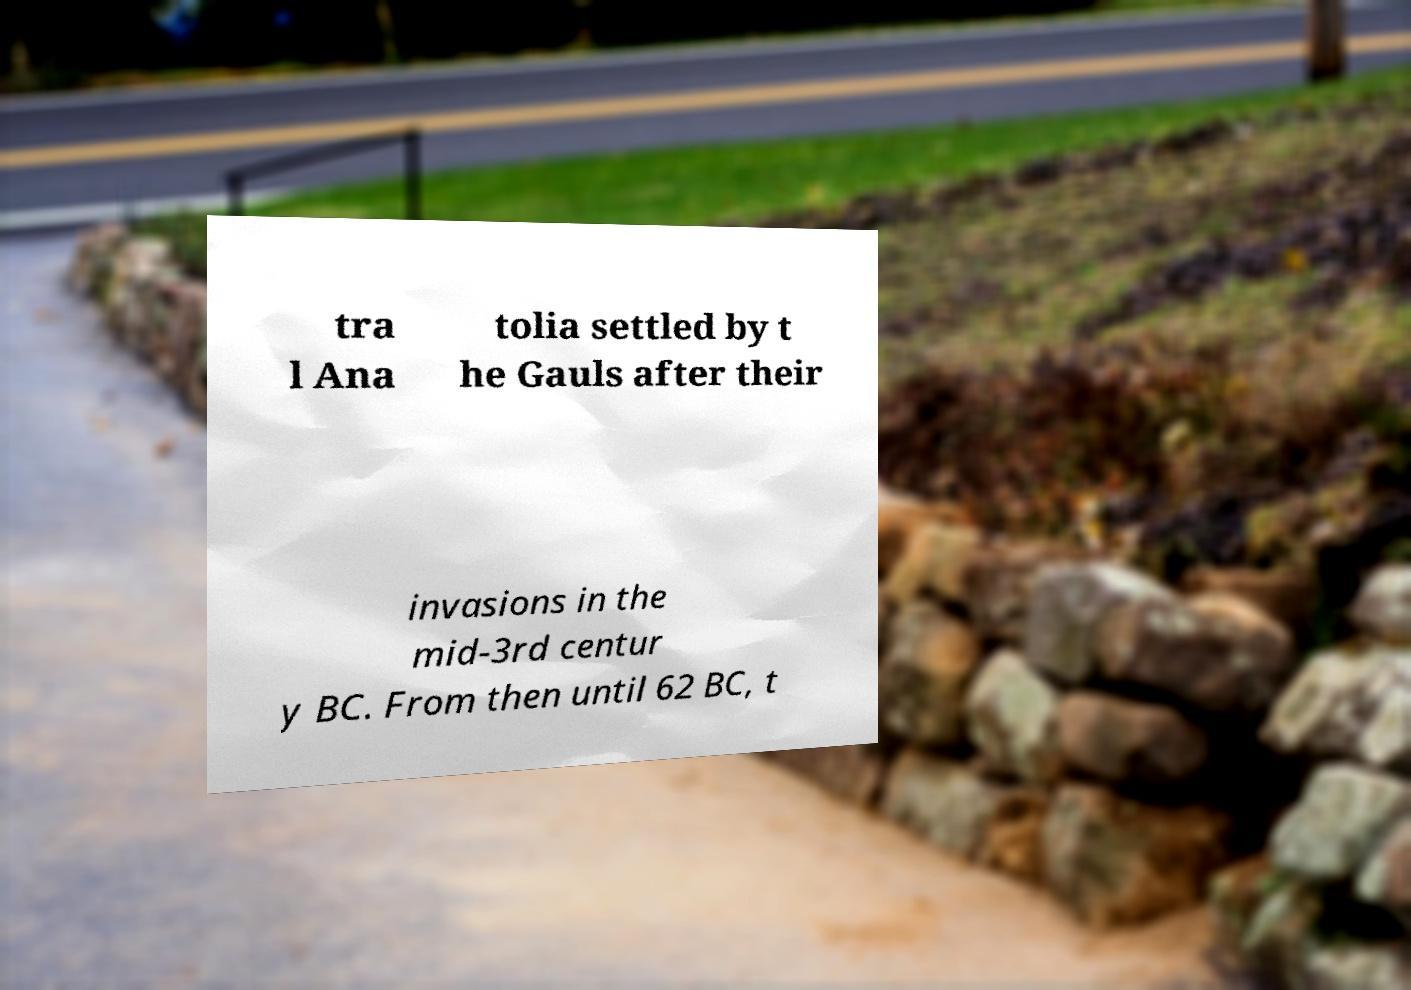There's text embedded in this image that I need extracted. Can you transcribe it verbatim? tra l Ana tolia settled by t he Gauls after their invasions in the mid-3rd centur y BC. From then until 62 BC, t 